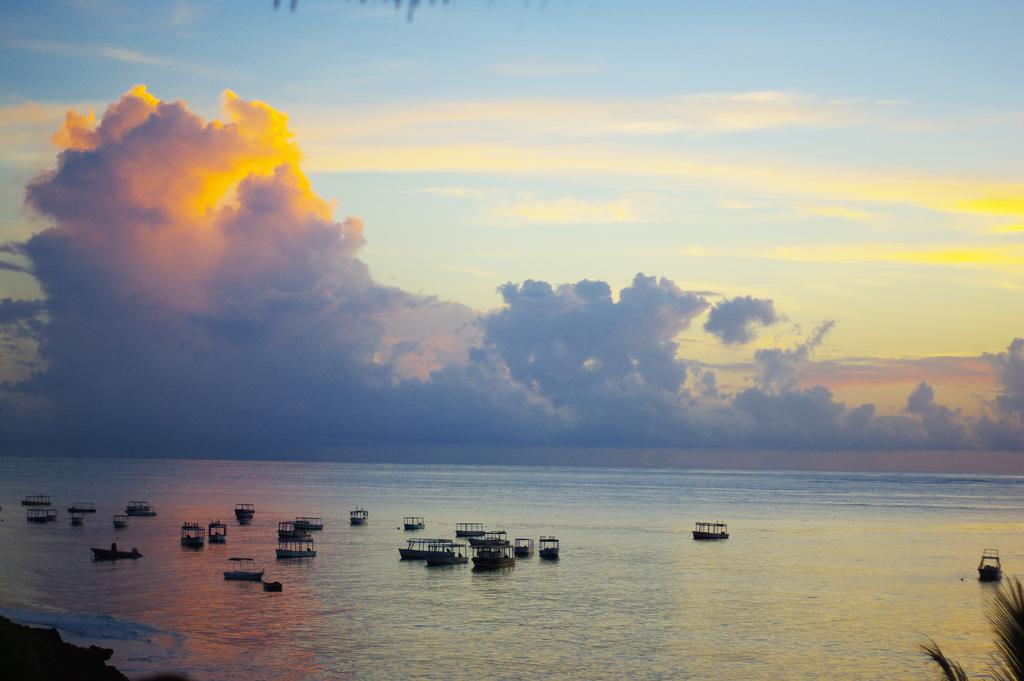What is the primary element in the boats are floating on in the image? There is water in the picture, and the boats are present in the water. How many boats can be seen in the image? There are many boats present in the water. What is the condition of the sky in the picture? The sky is clear in the picture. What type of bulb is being used to light up the boats in the image? There is no bulb present in the image; the boats are floating on water under a clear sky. Can you see a hose attached to any of the boats in the image? There is no hose visible in the image; the focus is on the boats in the water. 